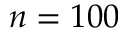Convert formula to latex. <formula><loc_0><loc_0><loc_500><loc_500>n = 1 0 0</formula> 